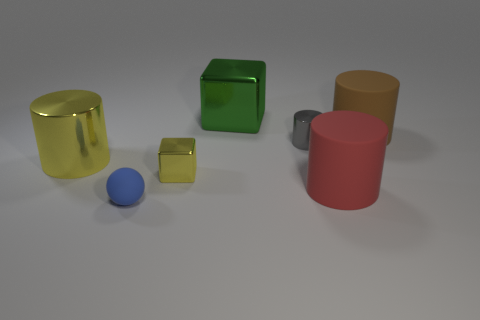Are there more metallic things that are in front of the big green thing than small yellow metal cubes that are behind the big brown cylinder?
Give a very brief answer. Yes. Are there more large rubber cylinders than large red rubber cubes?
Your answer should be compact. Yes. There is a object that is both in front of the small yellow shiny block and to the left of the tiny gray shiny object; how big is it?
Provide a succinct answer. Small. What is the shape of the small yellow metallic thing?
Provide a short and direct response. Cube. Is the number of big metal things right of the yellow cylinder greater than the number of brown balls?
Your response must be concise. Yes. What shape is the large shiny object behind the cylinder left of the tiny metallic thing behind the tiny yellow cube?
Ensure brevity in your answer.  Cube. There is a yellow metallic thing to the left of the matte ball; does it have the same size as the red thing?
Provide a succinct answer. Yes. There is a thing that is in front of the big yellow cylinder and to the left of the tiny yellow object; what is its shape?
Your answer should be very brief. Sphere. There is a small metallic cube; is its color the same as the object on the left side of the blue matte object?
Keep it short and to the point. Yes. What is the color of the rubber cylinder that is in front of the big rubber cylinder that is behind the cylinder that is in front of the tiny yellow block?
Make the answer very short. Red. 